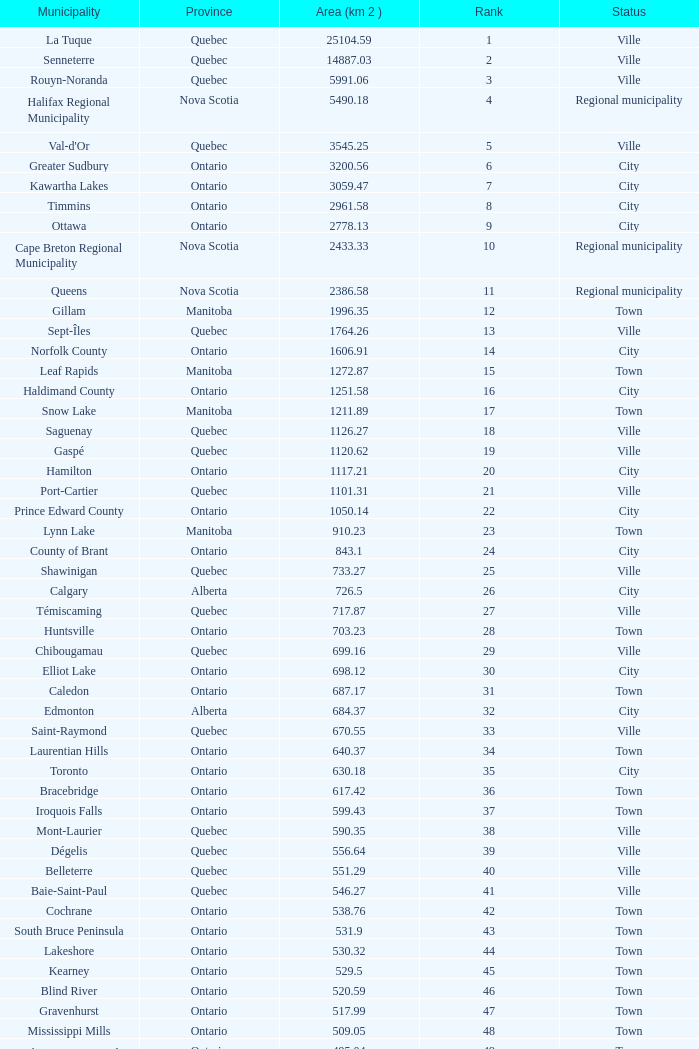What's the total of Rank that has an Area (KM 2) of 1050.14? 22.0. 